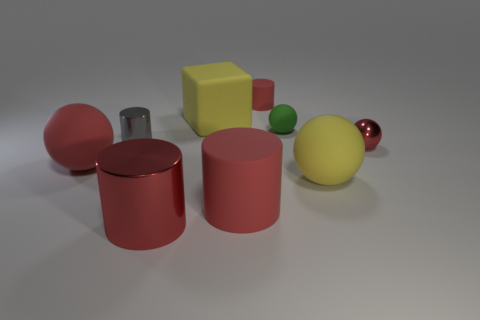Subtract all green spheres. How many red cylinders are left? 3 Subtract all cyan spheres. Subtract all yellow cubes. How many spheres are left? 4 Add 1 yellow matte blocks. How many objects exist? 10 Subtract all cubes. How many objects are left? 8 Add 1 yellow matte spheres. How many yellow matte spheres exist? 2 Subtract 1 green spheres. How many objects are left? 8 Subtract all small green spheres. Subtract all tiny yellow metal cubes. How many objects are left? 8 Add 7 small gray cylinders. How many small gray cylinders are left? 8 